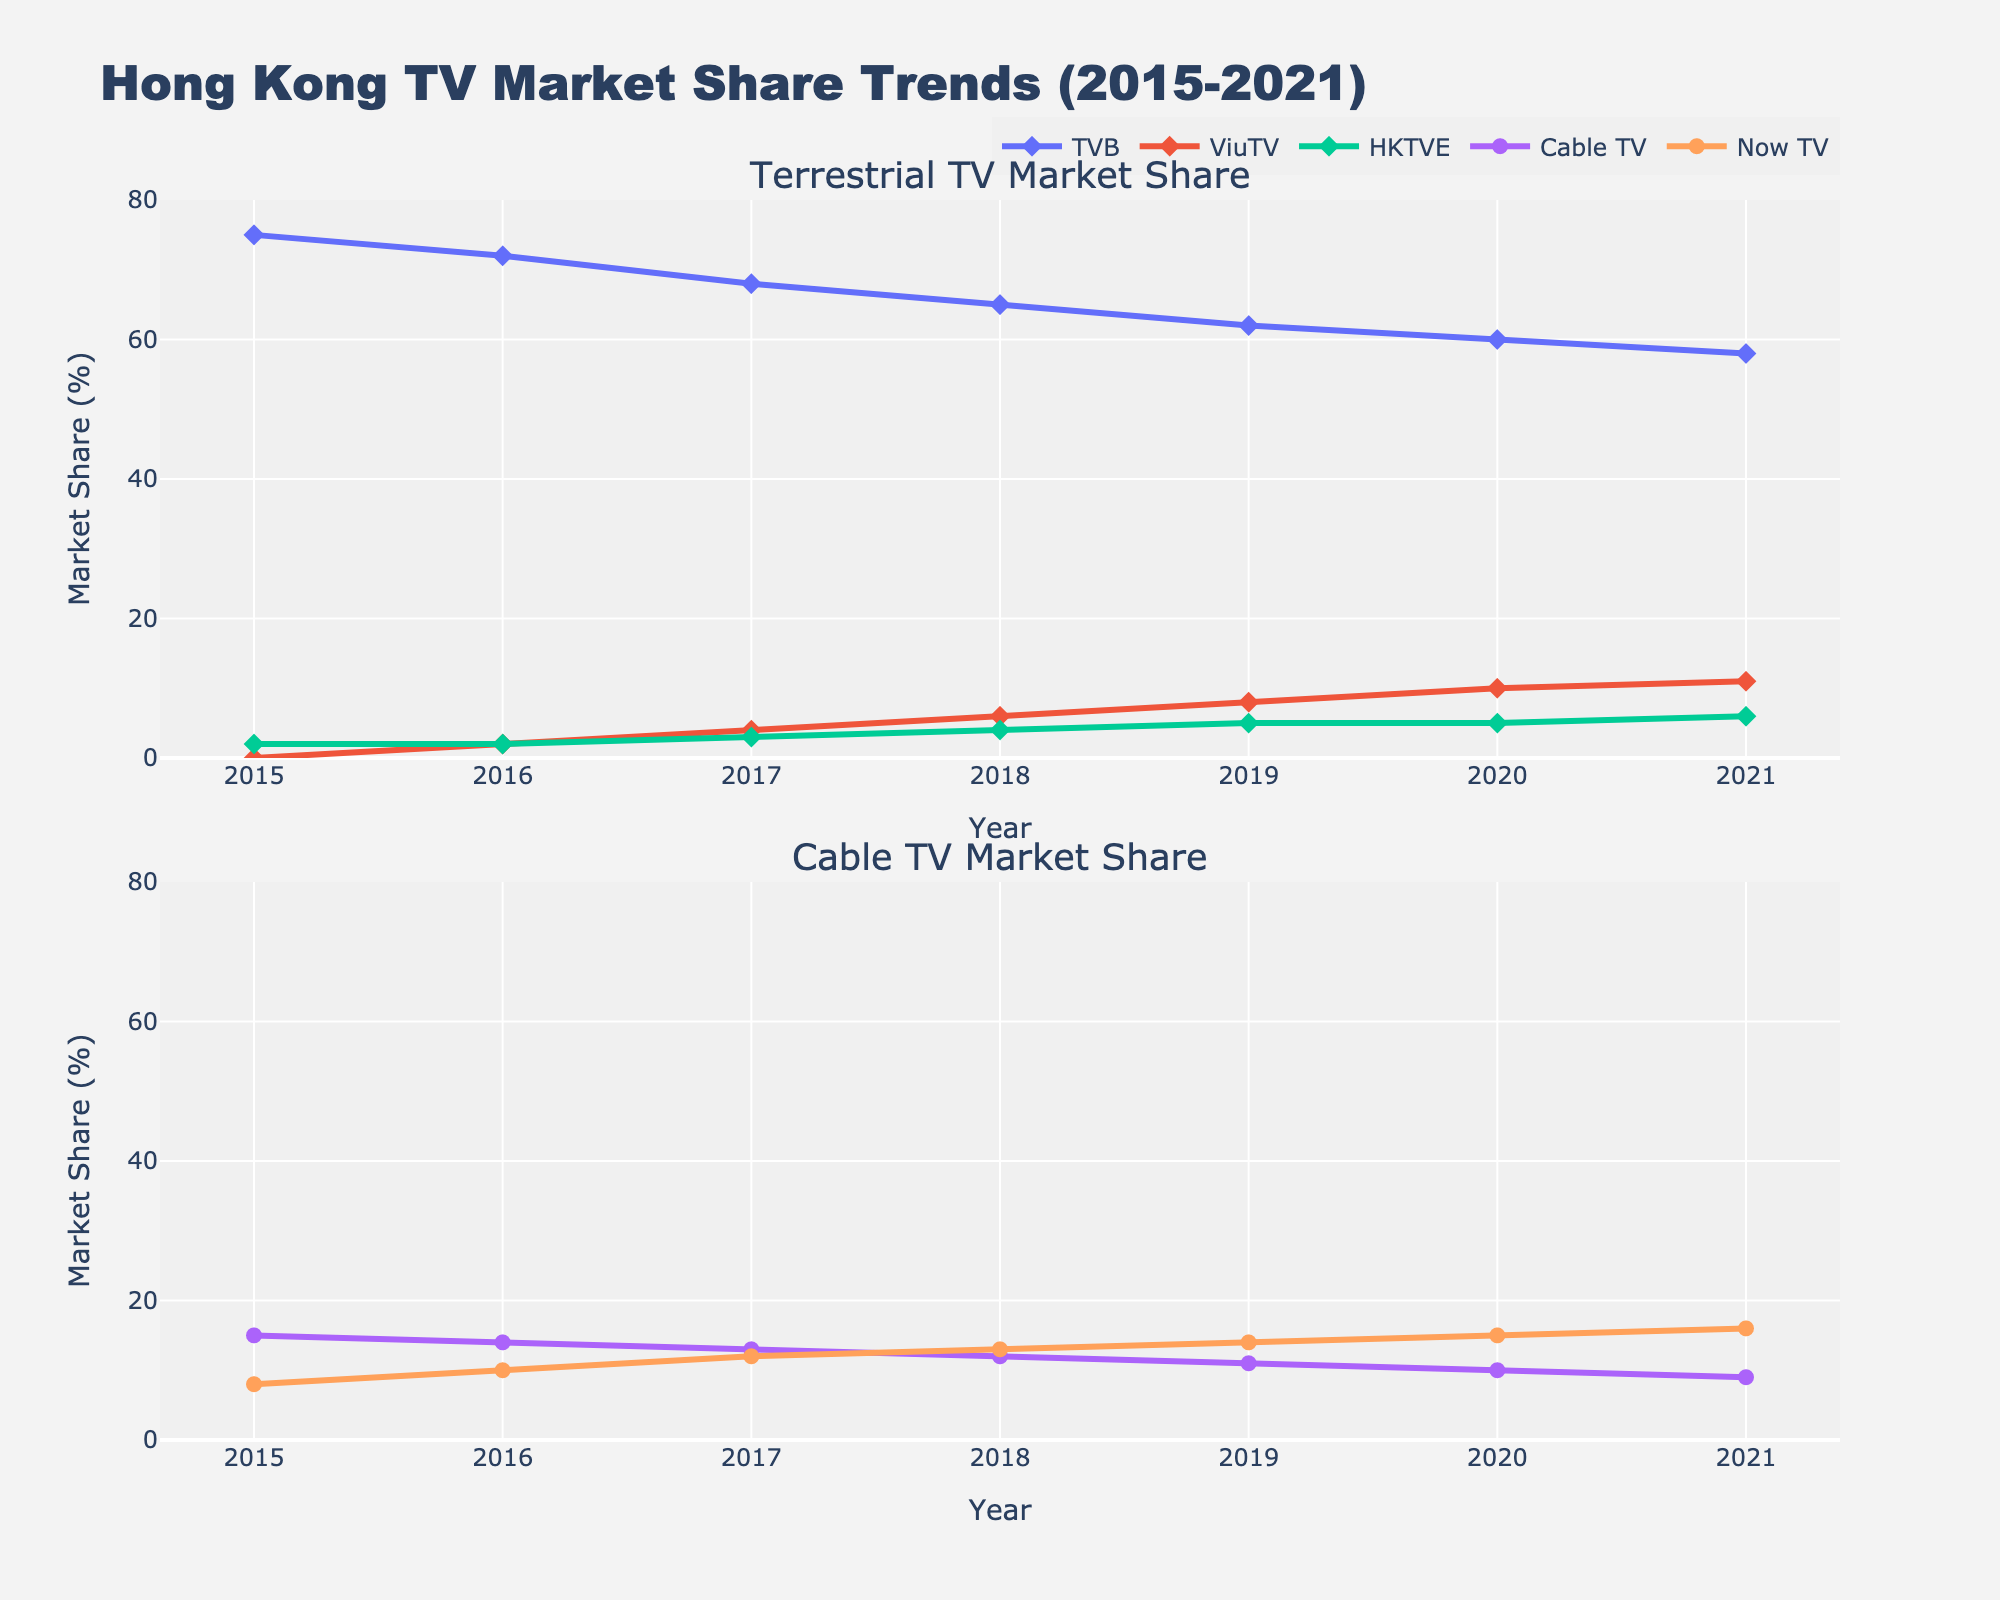What's the title of the plot? The title is usually located at the top of the plot. By referring to the figure, we can see the main title.
Answer: Hong Kong TV Market Share Trends (2015-2021) How many subplots are there in the figure? By looking at the layout of the figure, we can observe the division into separate sections.
Answer: Two Which terrestrial TV provider had the highest market share in 2021? We observe the first subplot focusing on terrestrial TV providers and check the data point for the year 2021.
Answer: TVB What is the market share difference between Now TV and Cable TV in 2017? Check the data points for Cable TV and Now TV in 2017 in the second subplot and take the difference (13% - 12%).
Answer: 1% Which TV provider showed the most growth from 2015 to 2021? Compare the market share values of each TV provider in 2015 and 2021, and calculate the overall differences. ViuTV shows an increase from 0% to 11%, which is the largest growth.
Answer: ViuTV What is the trend for TVB's market share from 2015 to 2021? Look at the line representing TVB in the first subplot and observe how it changes over time.
Answer: Decreasing In what year did ViuTV surpass Cable TV in market share? Compare the market share lines for ViuTV and Cable TV in the second subplot and see when ViuTV's line goes above Cable TV's line after 2016.
Answer: 2021 Which cable TV provider consistently had a lower market share from 2015 to 2021? Observe the lines for Cable TV and Now TV in the second subplot and compare their trends over all years.
Answer: Now TV How much did HKTVE's market share increase from 2018 to 2021? Check the data points for HKTVE in 2018 and 2021 in the first subplot, then calculate the increase (6% - 4%).
Answer: 2% What's the average market share of terrestrial TV providers in 2020? Sum the market shares of TVB, ViuTV, and HKTVE in 2020 and divide by 3: (60% + 10% + 5%) / 3.
Answer: 25% 